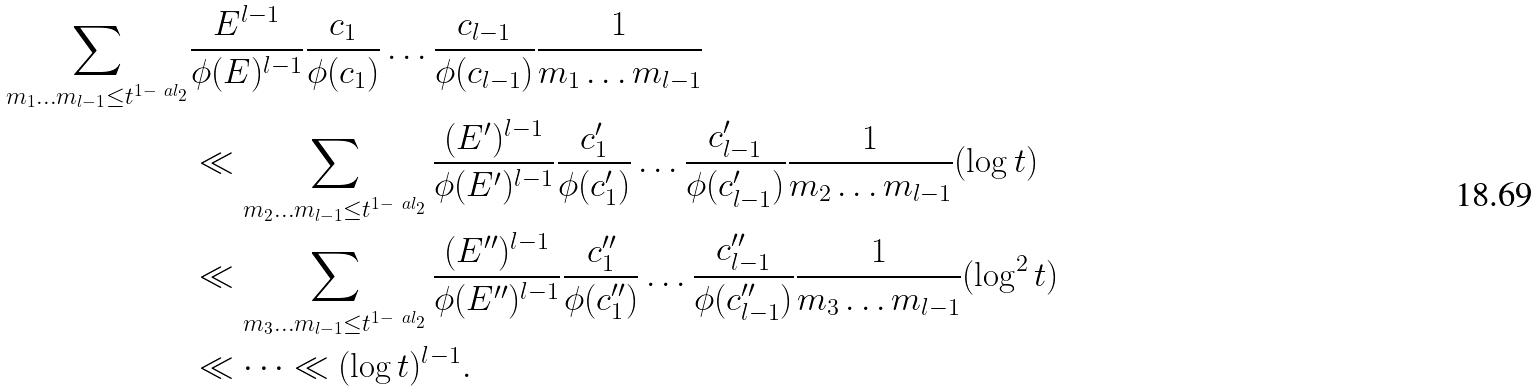Convert formula to latex. <formula><loc_0><loc_0><loc_500><loc_500>\sum _ { m _ { 1 } \dots m _ { l - 1 } \leq t ^ { 1 - \ a l _ { 2 } } } & \frac { E ^ { l - 1 } } { \phi ( E ) ^ { l - 1 } } \frac { c _ { 1 } } { \phi ( c _ { 1 } ) } \dots \frac { c _ { l - 1 } } { \phi ( c _ { l - 1 } ) } \frac { 1 } { m _ { 1 } \dots m _ { l - 1 } } \\ & \ll \sum _ { m _ { 2 } \dots m _ { l - 1 } \leq t ^ { 1 - \ a l _ { 2 } } } \frac { ( E ^ { \prime } ) ^ { l - 1 } } { \phi ( E ^ { \prime } ) ^ { l - 1 } } \frac { c ^ { \prime } _ { 1 } } { \phi ( c ^ { \prime } _ { 1 } ) } \dots \frac { c ^ { \prime } _ { l - 1 } } { \phi ( c ^ { \prime } _ { l - 1 } ) } \frac { 1 } { m _ { 2 } \dots m _ { l - 1 } } ( \log t ) \\ & \ll \sum _ { m _ { 3 } \dots m _ { l - 1 } \leq t ^ { 1 - \ a l _ { 2 } } } \frac { ( E ^ { \prime \prime } ) ^ { l - 1 } } { \phi ( E ^ { \prime \prime } ) ^ { l - 1 } } \frac { c ^ { \prime \prime } _ { 1 } } { \phi ( c ^ { \prime \prime } _ { 1 } ) } \dots \frac { c ^ { \prime \prime } _ { l - 1 } } { \phi ( c ^ { \prime \prime } _ { l - 1 } ) } \frac { 1 } { m _ { 3 } \dots m _ { l - 1 } } ( \log ^ { 2 } t ) \\ & \ll \dots \ll ( \log t ) ^ { l - 1 } .</formula> 